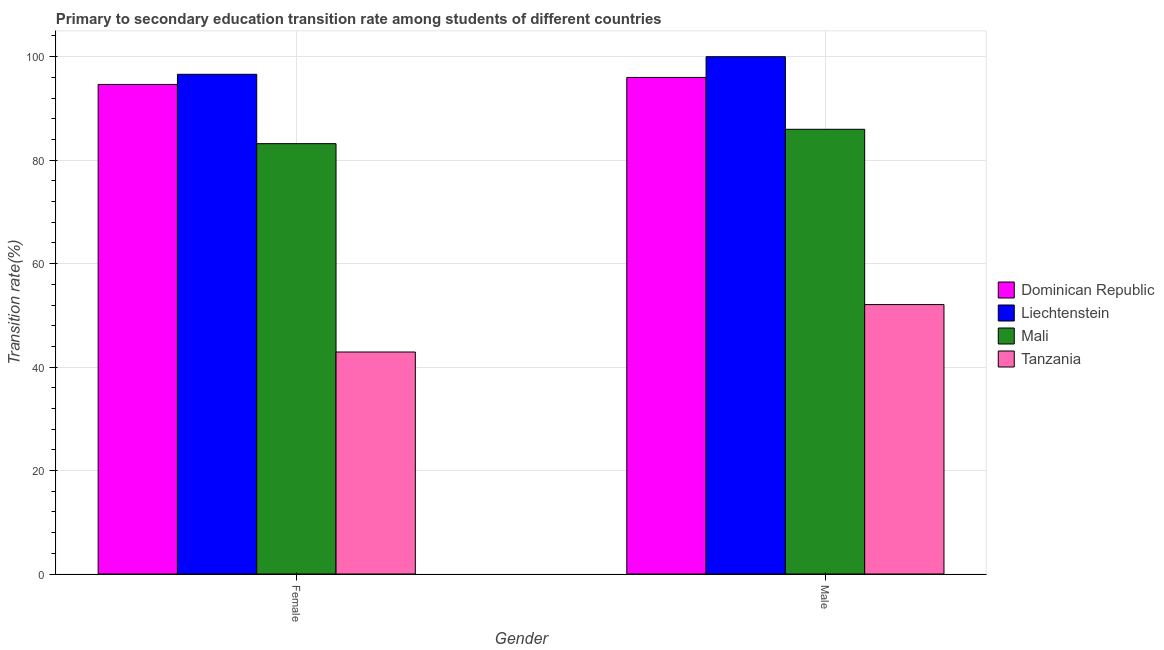Are the number of bars per tick equal to the number of legend labels?
Give a very brief answer. Yes. Are the number of bars on each tick of the X-axis equal?
Provide a short and direct response. Yes. What is the transition rate among male students in Dominican Republic?
Your answer should be very brief. 95.99. Across all countries, what is the maximum transition rate among male students?
Your answer should be very brief. 100. Across all countries, what is the minimum transition rate among female students?
Keep it short and to the point. 42.91. In which country was the transition rate among male students maximum?
Offer a very short reply. Liechtenstein. In which country was the transition rate among male students minimum?
Give a very brief answer. Tanzania. What is the total transition rate among female students in the graph?
Ensure brevity in your answer.  317.33. What is the difference between the transition rate among female students in Liechtenstein and that in Dominican Republic?
Offer a terse response. 1.96. What is the difference between the transition rate among female students in Mali and the transition rate among male students in Dominican Republic?
Give a very brief answer. -12.8. What is the average transition rate among female students per country?
Your answer should be very brief. 79.33. What is the difference between the transition rate among male students and transition rate among female students in Dominican Republic?
Keep it short and to the point. 1.36. In how many countries, is the transition rate among male students greater than 8 %?
Your answer should be very brief. 4. What is the ratio of the transition rate among male students in Dominican Republic to that in Tanzania?
Give a very brief answer. 1.84. Is the transition rate among female students in Mali less than that in Liechtenstein?
Offer a very short reply. Yes. What does the 4th bar from the left in Female represents?
Your answer should be very brief. Tanzania. What does the 1st bar from the right in Female represents?
Provide a short and direct response. Tanzania. How many bars are there?
Your response must be concise. 8. What is the difference between two consecutive major ticks on the Y-axis?
Your response must be concise. 20. How are the legend labels stacked?
Offer a very short reply. Vertical. What is the title of the graph?
Your response must be concise. Primary to secondary education transition rate among students of different countries. What is the label or title of the X-axis?
Give a very brief answer. Gender. What is the label or title of the Y-axis?
Give a very brief answer. Transition rate(%). What is the Transition rate(%) of Dominican Republic in Female?
Give a very brief answer. 94.63. What is the Transition rate(%) of Liechtenstein in Female?
Provide a succinct answer. 96.6. What is the Transition rate(%) in Mali in Female?
Provide a short and direct response. 83.19. What is the Transition rate(%) in Tanzania in Female?
Your response must be concise. 42.91. What is the Transition rate(%) of Dominican Republic in Male?
Your answer should be compact. 95.99. What is the Transition rate(%) in Mali in Male?
Offer a very short reply. 85.97. What is the Transition rate(%) in Tanzania in Male?
Give a very brief answer. 52.08. Across all Gender, what is the maximum Transition rate(%) of Dominican Republic?
Make the answer very short. 95.99. Across all Gender, what is the maximum Transition rate(%) of Liechtenstein?
Provide a short and direct response. 100. Across all Gender, what is the maximum Transition rate(%) of Mali?
Your answer should be compact. 85.97. Across all Gender, what is the maximum Transition rate(%) in Tanzania?
Offer a very short reply. 52.08. Across all Gender, what is the minimum Transition rate(%) of Dominican Republic?
Offer a terse response. 94.63. Across all Gender, what is the minimum Transition rate(%) of Liechtenstein?
Your answer should be compact. 96.6. Across all Gender, what is the minimum Transition rate(%) in Mali?
Your answer should be very brief. 83.19. Across all Gender, what is the minimum Transition rate(%) in Tanzania?
Ensure brevity in your answer.  42.91. What is the total Transition rate(%) of Dominican Republic in the graph?
Offer a terse response. 190.63. What is the total Transition rate(%) in Liechtenstein in the graph?
Make the answer very short. 196.6. What is the total Transition rate(%) in Mali in the graph?
Provide a short and direct response. 169.15. What is the total Transition rate(%) in Tanzania in the graph?
Keep it short and to the point. 94.99. What is the difference between the Transition rate(%) in Dominican Republic in Female and that in Male?
Provide a succinct answer. -1.36. What is the difference between the Transition rate(%) in Liechtenstein in Female and that in Male?
Provide a short and direct response. -3.4. What is the difference between the Transition rate(%) of Mali in Female and that in Male?
Keep it short and to the point. -2.78. What is the difference between the Transition rate(%) in Tanzania in Female and that in Male?
Make the answer very short. -9.16. What is the difference between the Transition rate(%) of Dominican Republic in Female and the Transition rate(%) of Liechtenstein in Male?
Your answer should be very brief. -5.37. What is the difference between the Transition rate(%) in Dominican Republic in Female and the Transition rate(%) in Mali in Male?
Your answer should be very brief. 8.67. What is the difference between the Transition rate(%) in Dominican Republic in Female and the Transition rate(%) in Tanzania in Male?
Your answer should be very brief. 42.55. What is the difference between the Transition rate(%) of Liechtenstein in Female and the Transition rate(%) of Mali in Male?
Provide a succinct answer. 10.63. What is the difference between the Transition rate(%) of Liechtenstein in Female and the Transition rate(%) of Tanzania in Male?
Ensure brevity in your answer.  44.52. What is the difference between the Transition rate(%) of Mali in Female and the Transition rate(%) of Tanzania in Male?
Offer a very short reply. 31.11. What is the average Transition rate(%) in Dominican Republic per Gender?
Your response must be concise. 95.31. What is the average Transition rate(%) of Liechtenstein per Gender?
Offer a terse response. 98.3. What is the average Transition rate(%) in Mali per Gender?
Make the answer very short. 84.58. What is the average Transition rate(%) of Tanzania per Gender?
Provide a succinct answer. 47.5. What is the difference between the Transition rate(%) in Dominican Republic and Transition rate(%) in Liechtenstein in Female?
Your answer should be very brief. -1.96. What is the difference between the Transition rate(%) of Dominican Republic and Transition rate(%) of Mali in Female?
Give a very brief answer. 11.45. What is the difference between the Transition rate(%) in Dominican Republic and Transition rate(%) in Tanzania in Female?
Give a very brief answer. 51.72. What is the difference between the Transition rate(%) in Liechtenstein and Transition rate(%) in Mali in Female?
Keep it short and to the point. 13.41. What is the difference between the Transition rate(%) in Liechtenstein and Transition rate(%) in Tanzania in Female?
Your answer should be compact. 53.68. What is the difference between the Transition rate(%) in Mali and Transition rate(%) in Tanzania in Female?
Your answer should be compact. 40.27. What is the difference between the Transition rate(%) of Dominican Republic and Transition rate(%) of Liechtenstein in Male?
Your answer should be very brief. -4.01. What is the difference between the Transition rate(%) in Dominican Republic and Transition rate(%) in Mali in Male?
Provide a short and direct response. 10.03. What is the difference between the Transition rate(%) of Dominican Republic and Transition rate(%) of Tanzania in Male?
Your answer should be compact. 43.91. What is the difference between the Transition rate(%) of Liechtenstein and Transition rate(%) of Mali in Male?
Offer a very short reply. 14.03. What is the difference between the Transition rate(%) in Liechtenstein and Transition rate(%) in Tanzania in Male?
Your response must be concise. 47.92. What is the difference between the Transition rate(%) in Mali and Transition rate(%) in Tanzania in Male?
Ensure brevity in your answer.  33.89. What is the ratio of the Transition rate(%) in Dominican Republic in Female to that in Male?
Your response must be concise. 0.99. What is the ratio of the Transition rate(%) in Tanzania in Female to that in Male?
Make the answer very short. 0.82. What is the difference between the highest and the second highest Transition rate(%) in Dominican Republic?
Provide a succinct answer. 1.36. What is the difference between the highest and the second highest Transition rate(%) in Liechtenstein?
Offer a very short reply. 3.4. What is the difference between the highest and the second highest Transition rate(%) in Mali?
Ensure brevity in your answer.  2.78. What is the difference between the highest and the second highest Transition rate(%) of Tanzania?
Your answer should be compact. 9.16. What is the difference between the highest and the lowest Transition rate(%) in Dominican Republic?
Provide a succinct answer. 1.36. What is the difference between the highest and the lowest Transition rate(%) in Liechtenstein?
Your answer should be compact. 3.4. What is the difference between the highest and the lowest Transition rate(%) of Mali?
Provide a short and direct response. 2.78. What is the difference between the highest and the lowest Transition rate(%) of Tanzania?
Provide a succinct answer. 9.16. 